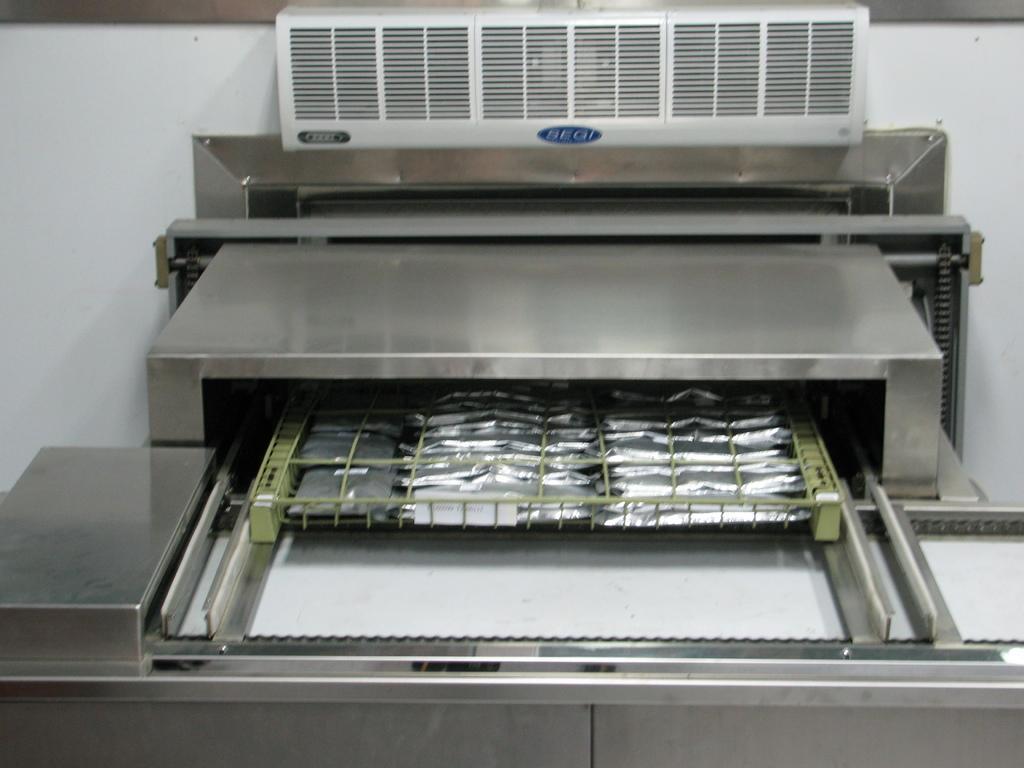How would you summarize this image in a sentence or two? In the image there is machine in the front with a conveyor belt and a tray in the middle of it, in the back it seems to be ac vent on the wall. 